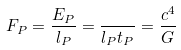<formula> <loc_0><loc_0><loc_500><loc_500>F _ { P } = { \frac { E _ { P } } { l _ { P } } } = { \frac { } { l _ { P } t _ { P } } } = { \frac { c ^ { 4 } } { G } }</formula> 